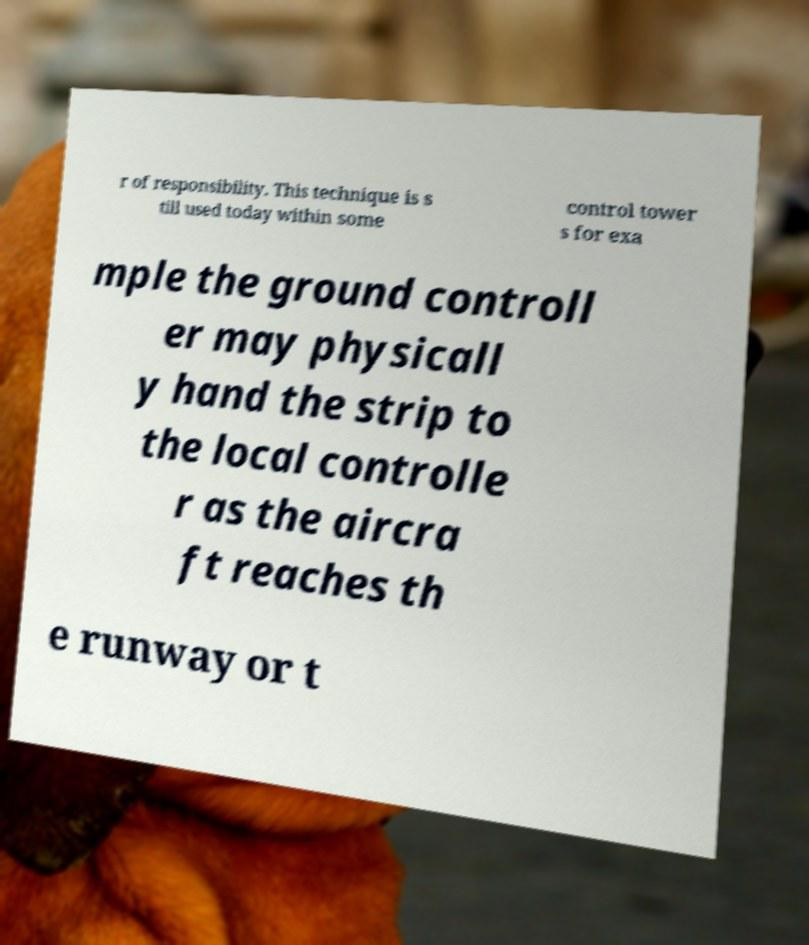Could you assist in decoding the text presented in this image and type it out clearly? r of responsibility. This technique is s till used today within some control tower s for exa mple the ground controll er may physicall y hand the strip to the local controlle r as the aircra ft reaches th e runway or t 